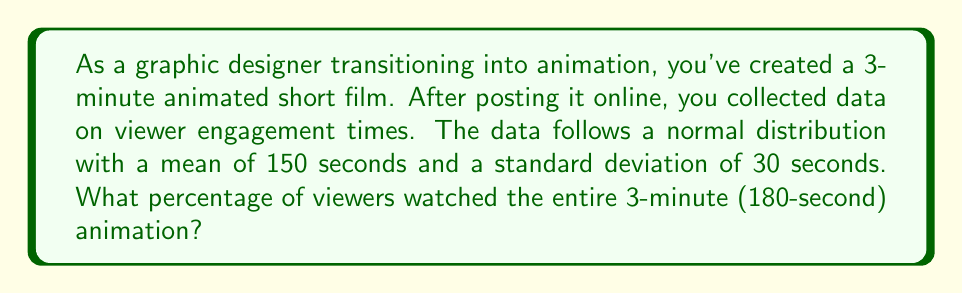Can you answer this question? To solve this problem, we need to use the properties of the normal distribution and calculate the z-score for the full viewing time.

Step 1: Identify the given information
- Mean ($\mu$) = 150 seconds
- Standard deviation ($\sigma$) = 30 seconds
- Full viewing time = 180 seconds

Step 2: Calculate the z-score for 180 seconds
The z-score formula is: $z = \frac{x - \mu}{\sigma}$

Substituting the values:
$z = \frac{180 - 150}{30} = \frac{30}{30} = 1$

Step 3: Use the standard normal distribution table or calculator
We need to find the area to the right of z = 1 on the standard normal distribution curve. This represents the probability of a viewer watching the entire animation.

Using a standard normal distribution table or calculator, we find:
P(Z > 1) ≈ 0.1587

Step 4: Convert the probability to a percentage
0.1587 × 100% ≈ 15.87%

Therefore, approximately 15.87% of viewers watched the entire 3-minute animation.
Answer: 15.87% 